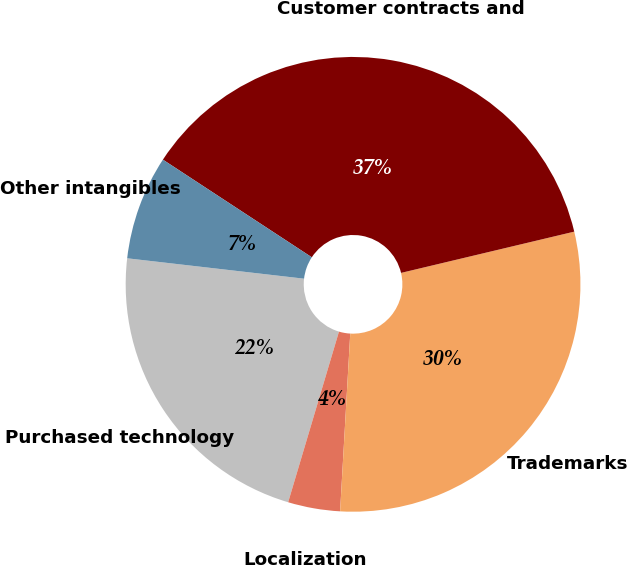Convert chart. <chart><loc_0><loc_0><loc_500><loc_500><pie_chart><fcel>Purchased technology<fcel>Localization<fcel>Trademarks<fcel>Customer contracts and<fcel>Other intangibles<nl><fcel>22.22%<fcel>3.7%<fcel>29.63%<fcel>37.04%<fcel>7.41%<nl></chart> 